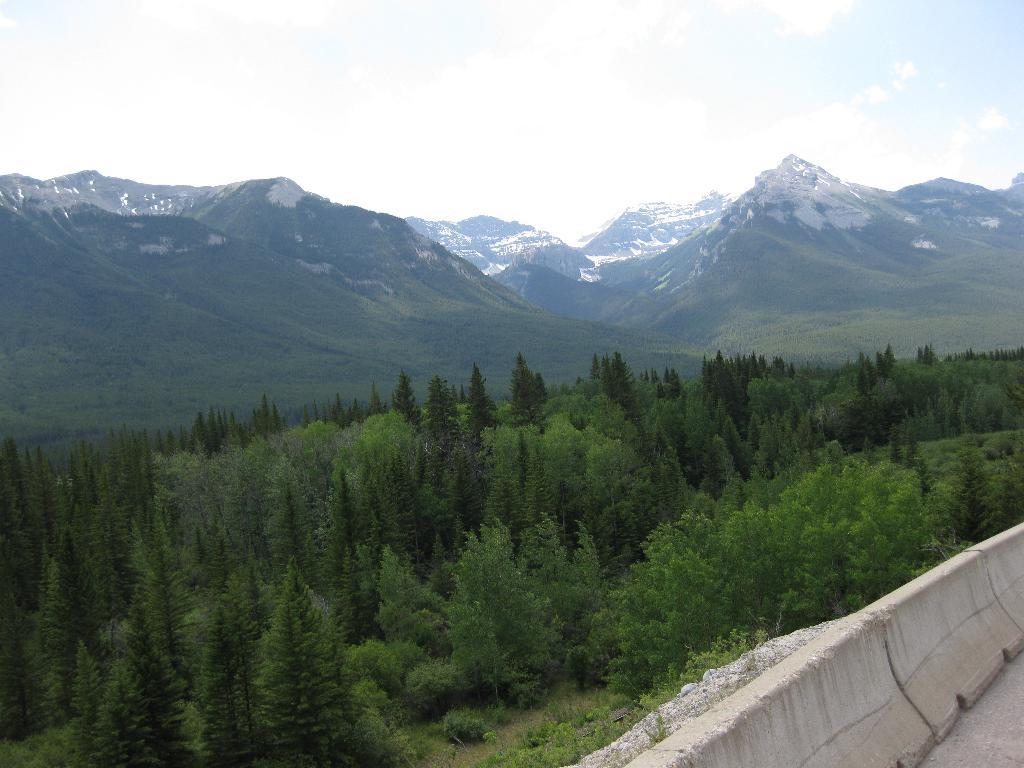What is located in the front of the image? There are trees and a wall in the front of the image. What can be seen in the background of the image? There are mountains and a cloudy sky in the background of the image. What type of lettuce is growing on the wall in the image? There is no lettuce present in the image; the wall is not a garden or a place where plants would grow. 